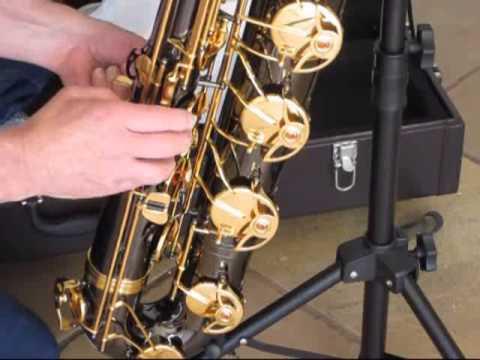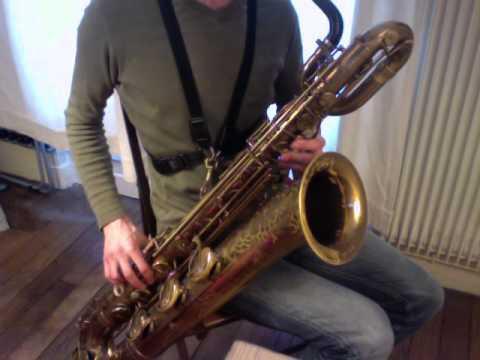The first image is the image on the left, the second image is the image on the right. Examine the images to the left and right. Is the description "A person wearing glasses holds a saxophone in the left image." accurate? Answer yes or no. No. The first image is the image on the left, the second image is the image on the right. For the images displayed, is the sentence "An image shows a person in a green shirt and jeans holding an instrument." factually correct? Answer yes or no. Yes. 